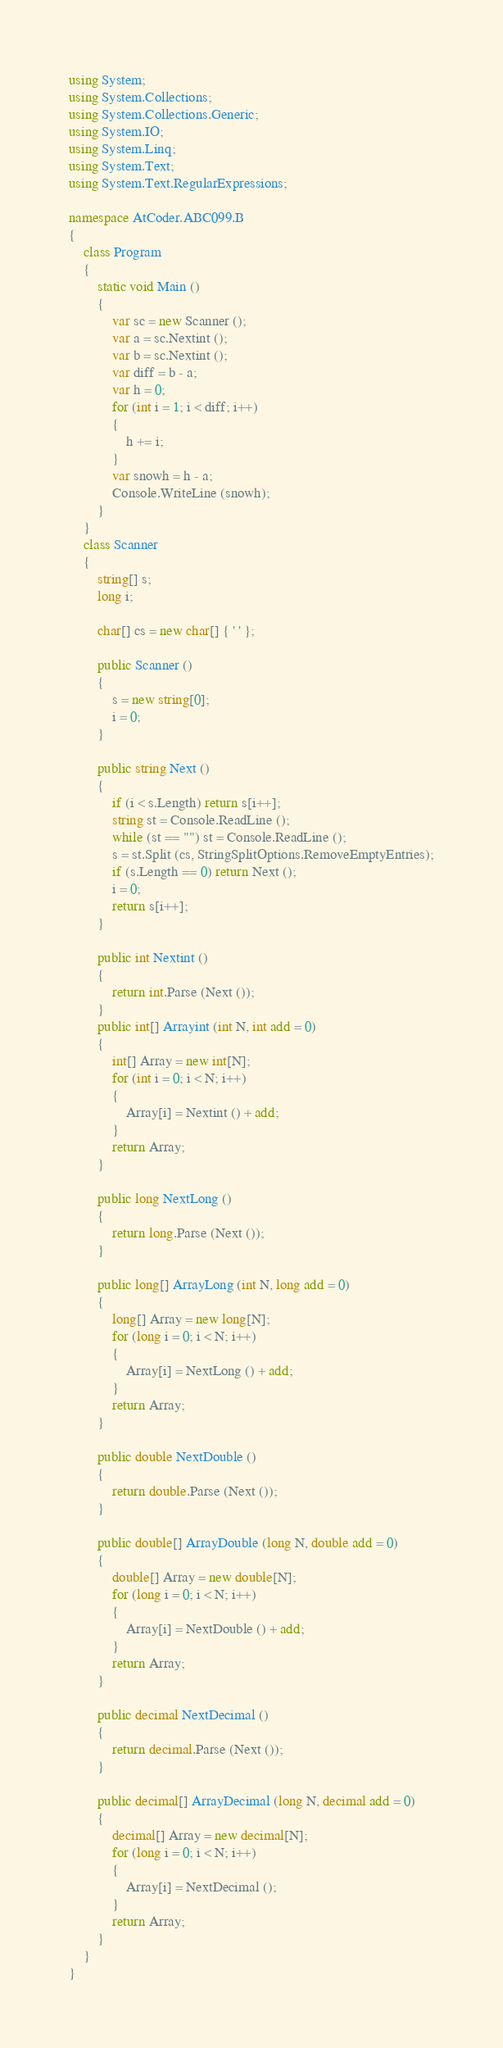Convert code to text. <code><loc_0><loc_0><loc_500><loc_500><_C#_>using System;
using System.Collections;
using System.Collections.Generic;
using System.IO;
using System.Linq;
using System.Text;
using System.Text.RegularExpressions;

namespace AtCoder.ABC099.B
{
    class Program
    {
        static void Main ()
        {
            var sc = new Scanner ();
            var a = sc.Nextint ();
            var b = sc.Nextint ();
            var diff = b - a;
            var h = 0;
            for (int i = 1; i < diff; i++)
            {
                h += i;
            }
            var snowh = h - a;
            Console.WriteLine (snowh);
        }
    }
    class Scanner
    {
        string[] s;
        long i;

        char[] cs = new char[] { ' ' };

        public Scanner ()
        {
            s = new string[0];
            i = 0;
        }

        public string Next ()
        {
            if (i < s.Length) return s[i++];
            string st = Console.ReadLine ();
            while (st == "") st = Console.ReadLine ();
            s = st.Split (cs, StringSplitOptions.RemoveEmptyEntries);
            if (s.Length == 0) return Next ();
            i = 0;
            return s[i++];
        }

        public int Nextint ()
        {
            return int.Parse (Next ());
        }
        public int[] Arrayint (int N, int add = 0)
        {
            int[] Array = new int[N];
            for (int i = 0; i < N; i++)
            {
                Array[i] = Nextint () + add;
            }
            return Array;
        }

        public long NextLong ()
        {
            return long.Parse (Next ());
        }

        public long[] ArrayLong (int N, long add = 0)
        {
            long[] Array = new long[N];
            for (long i = 0; i < N; i++)
            {
                Array[i] = NextLong () + add;
            }
            return Array;
        }

        public double NextDouble ()
        {
            return double.Parse (Next ());
        }

        public double[] ArrayDouble (long N, double add = 0)
        {
            double[] Array = new double[N];
            for (long i = 0; i < N; i++)
            {
                Array[i] = NextDouble () + add;
            }
            return Array;
        }

        public decimal NextDecimal ()
        {
            return decimal.Parse (Next ());
        }

        public decimal[] ArrayDecimal (long N, decimal add = 0)
        {
            decimal[] Array = new decimal[N];
            for (long i = 0; i < N; i++)
            {
                Array[i] = NextDecimal ();
            }
            return Array;
        }
    }
}</code> 